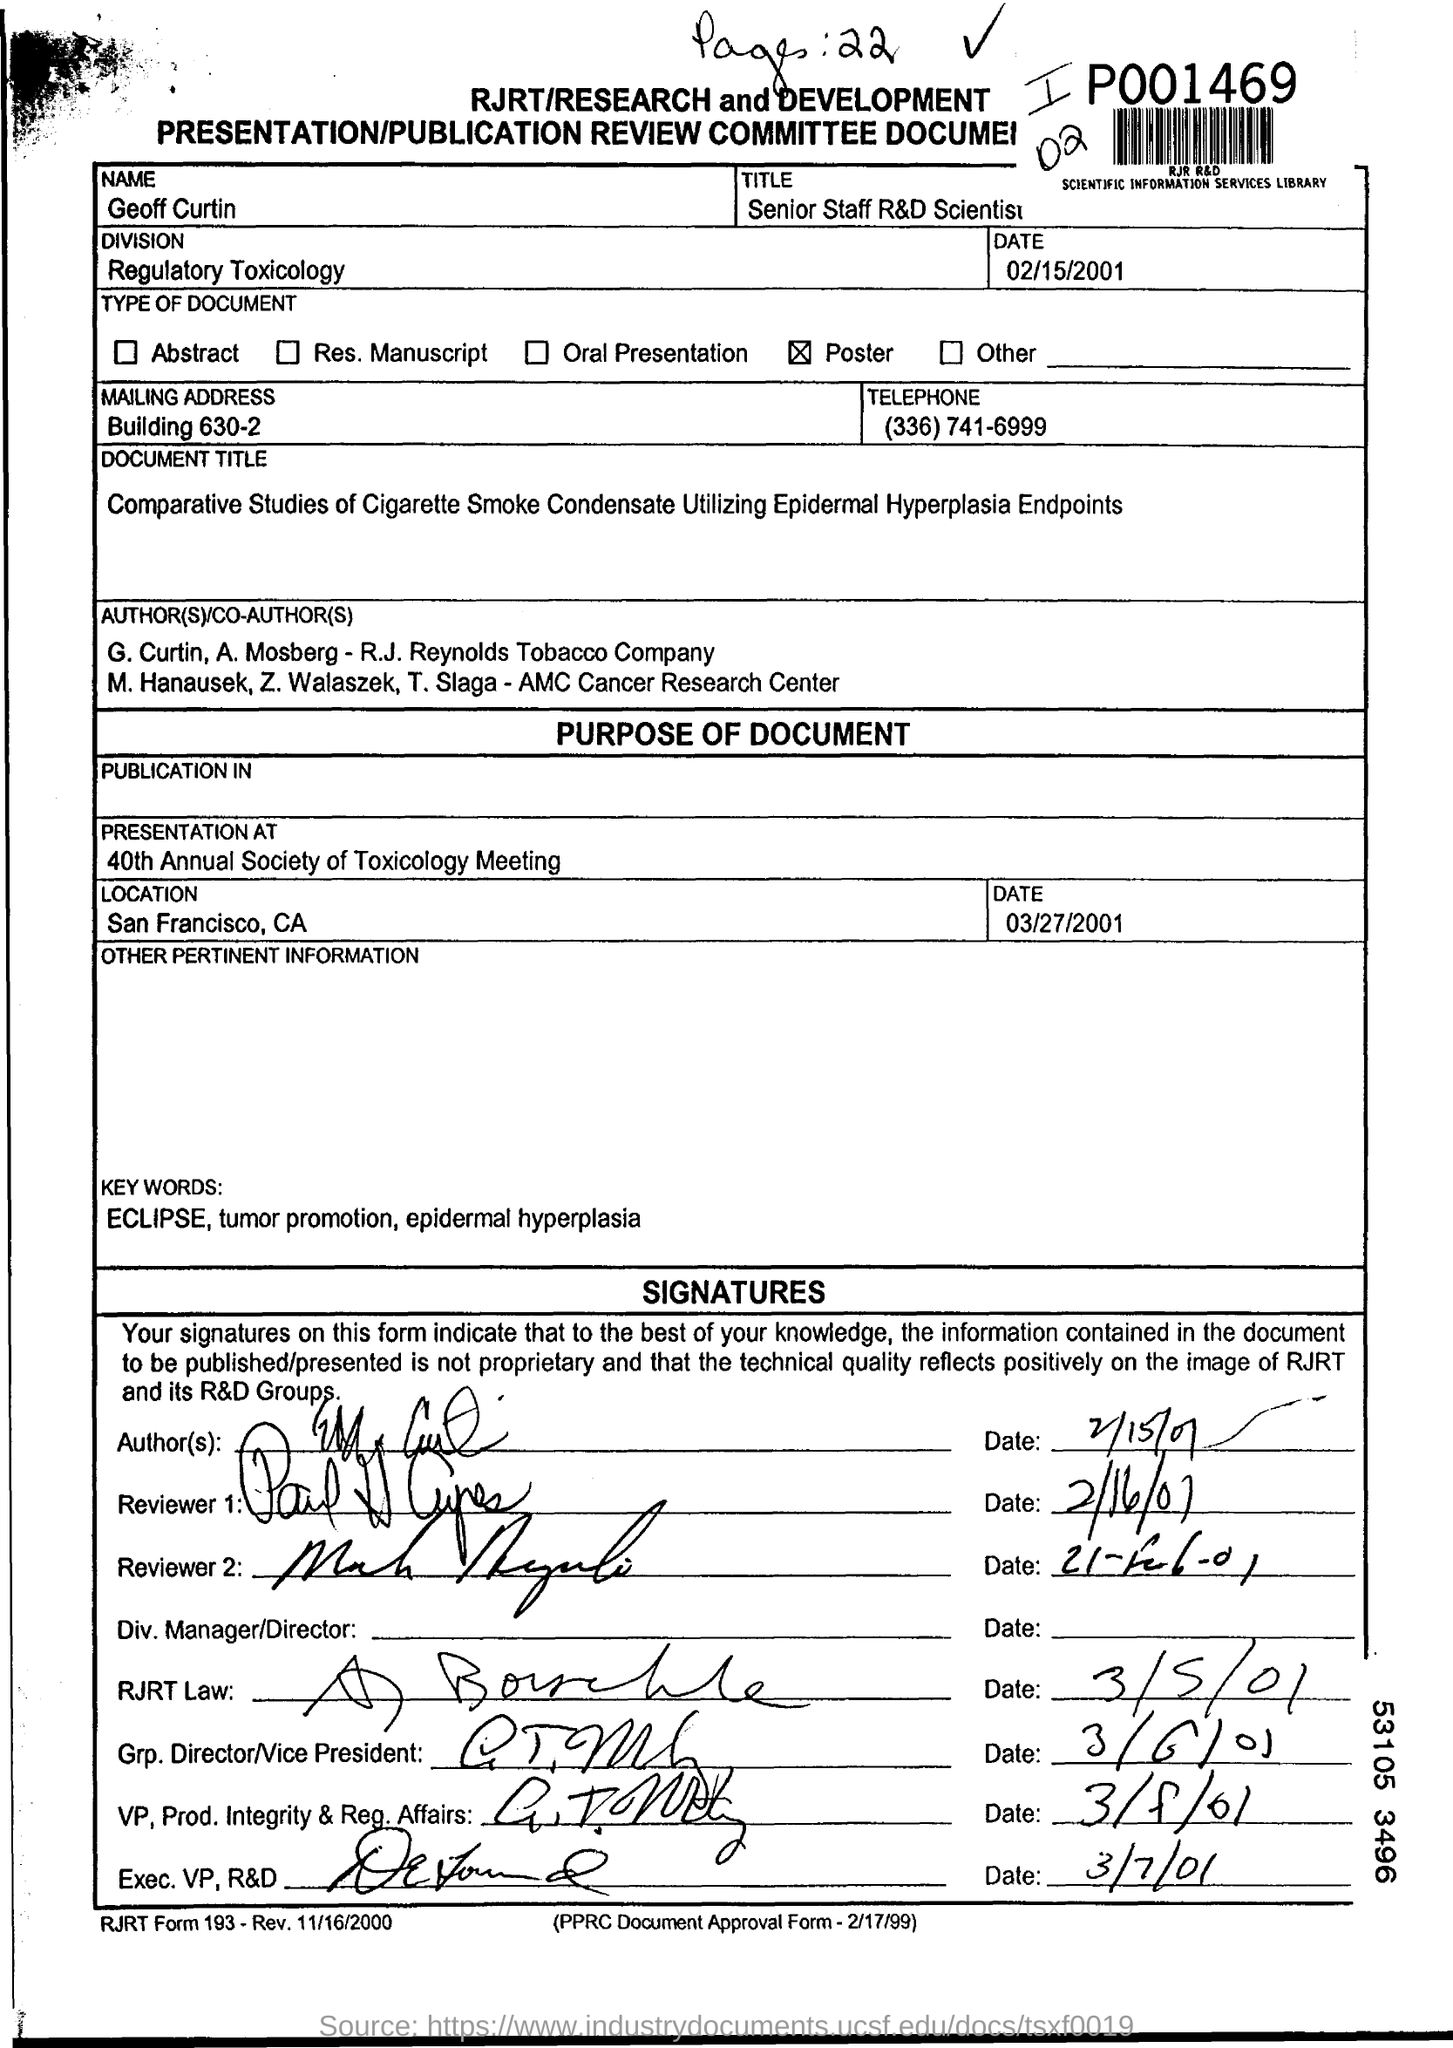What is the title of Geoff Curtin?
Provide a short and direct response. Senior Staff R&D Scientist. Which division is mentioned?
Provide a short and direct response. Regulatory Toxicology. What is the type of document?
Make the answer very short. Poster. What is the name of the person mentioned in the form?
Offer a terse response. Geoff Curtin. Where is the presentation at?
Keep it short and to the point. 40th annual society of toxicology meeting. Where is the location of the presentation?
Your response must be concise. San francisco , ca. 